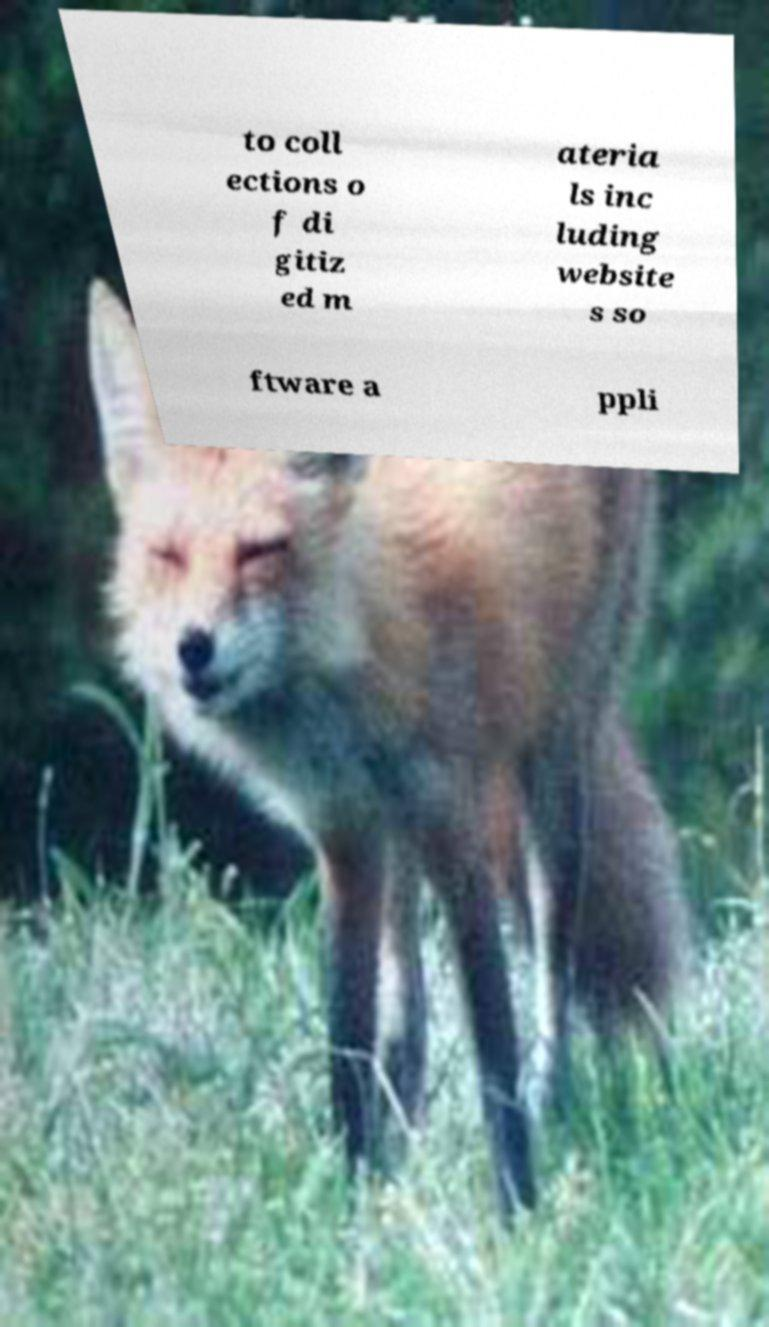Please identify and transcribe the text found in this image. to coll ections o f di gitiz ed m ateria ls inc luding website s so ftware a ppli 